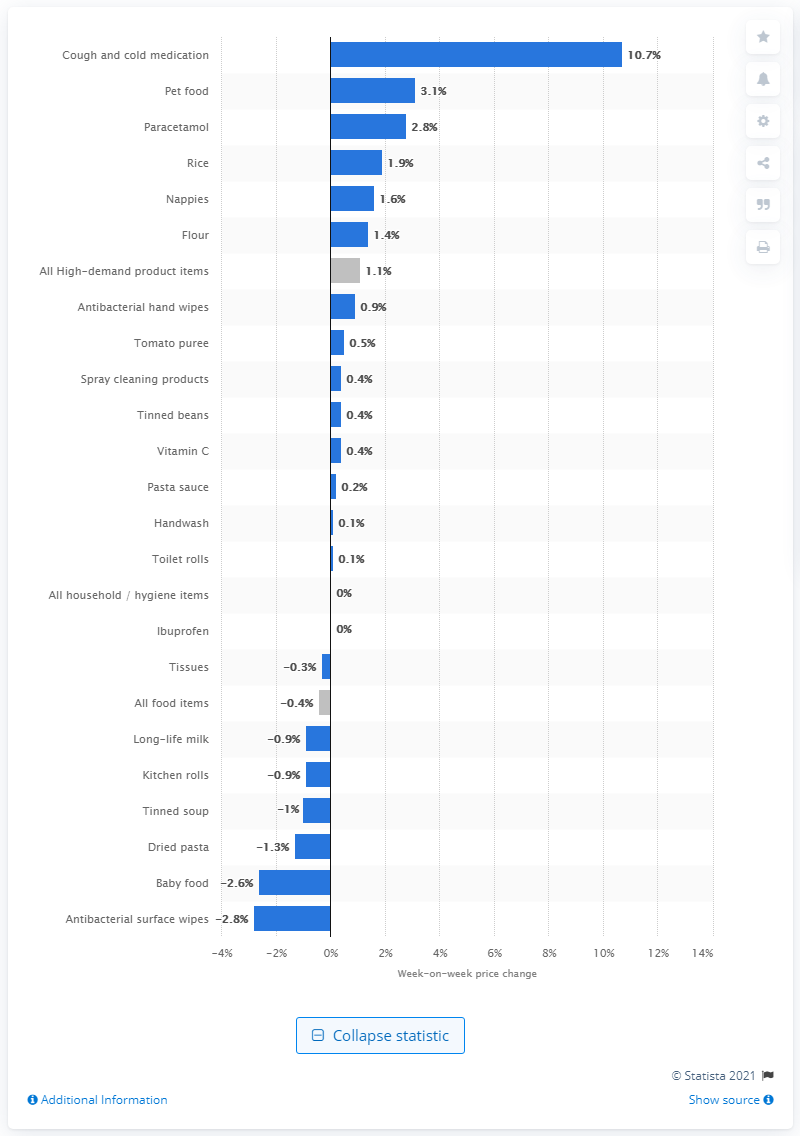Draw attention to some important aspects in this diagram. The cost of purchasing cough and cold medications online in the United Kingdom increased by 10.7% in the past year. The price of antibacterial surface wipes has decreased by 2.8%. The price increase of pet food has been recorded to be 3.1%. 